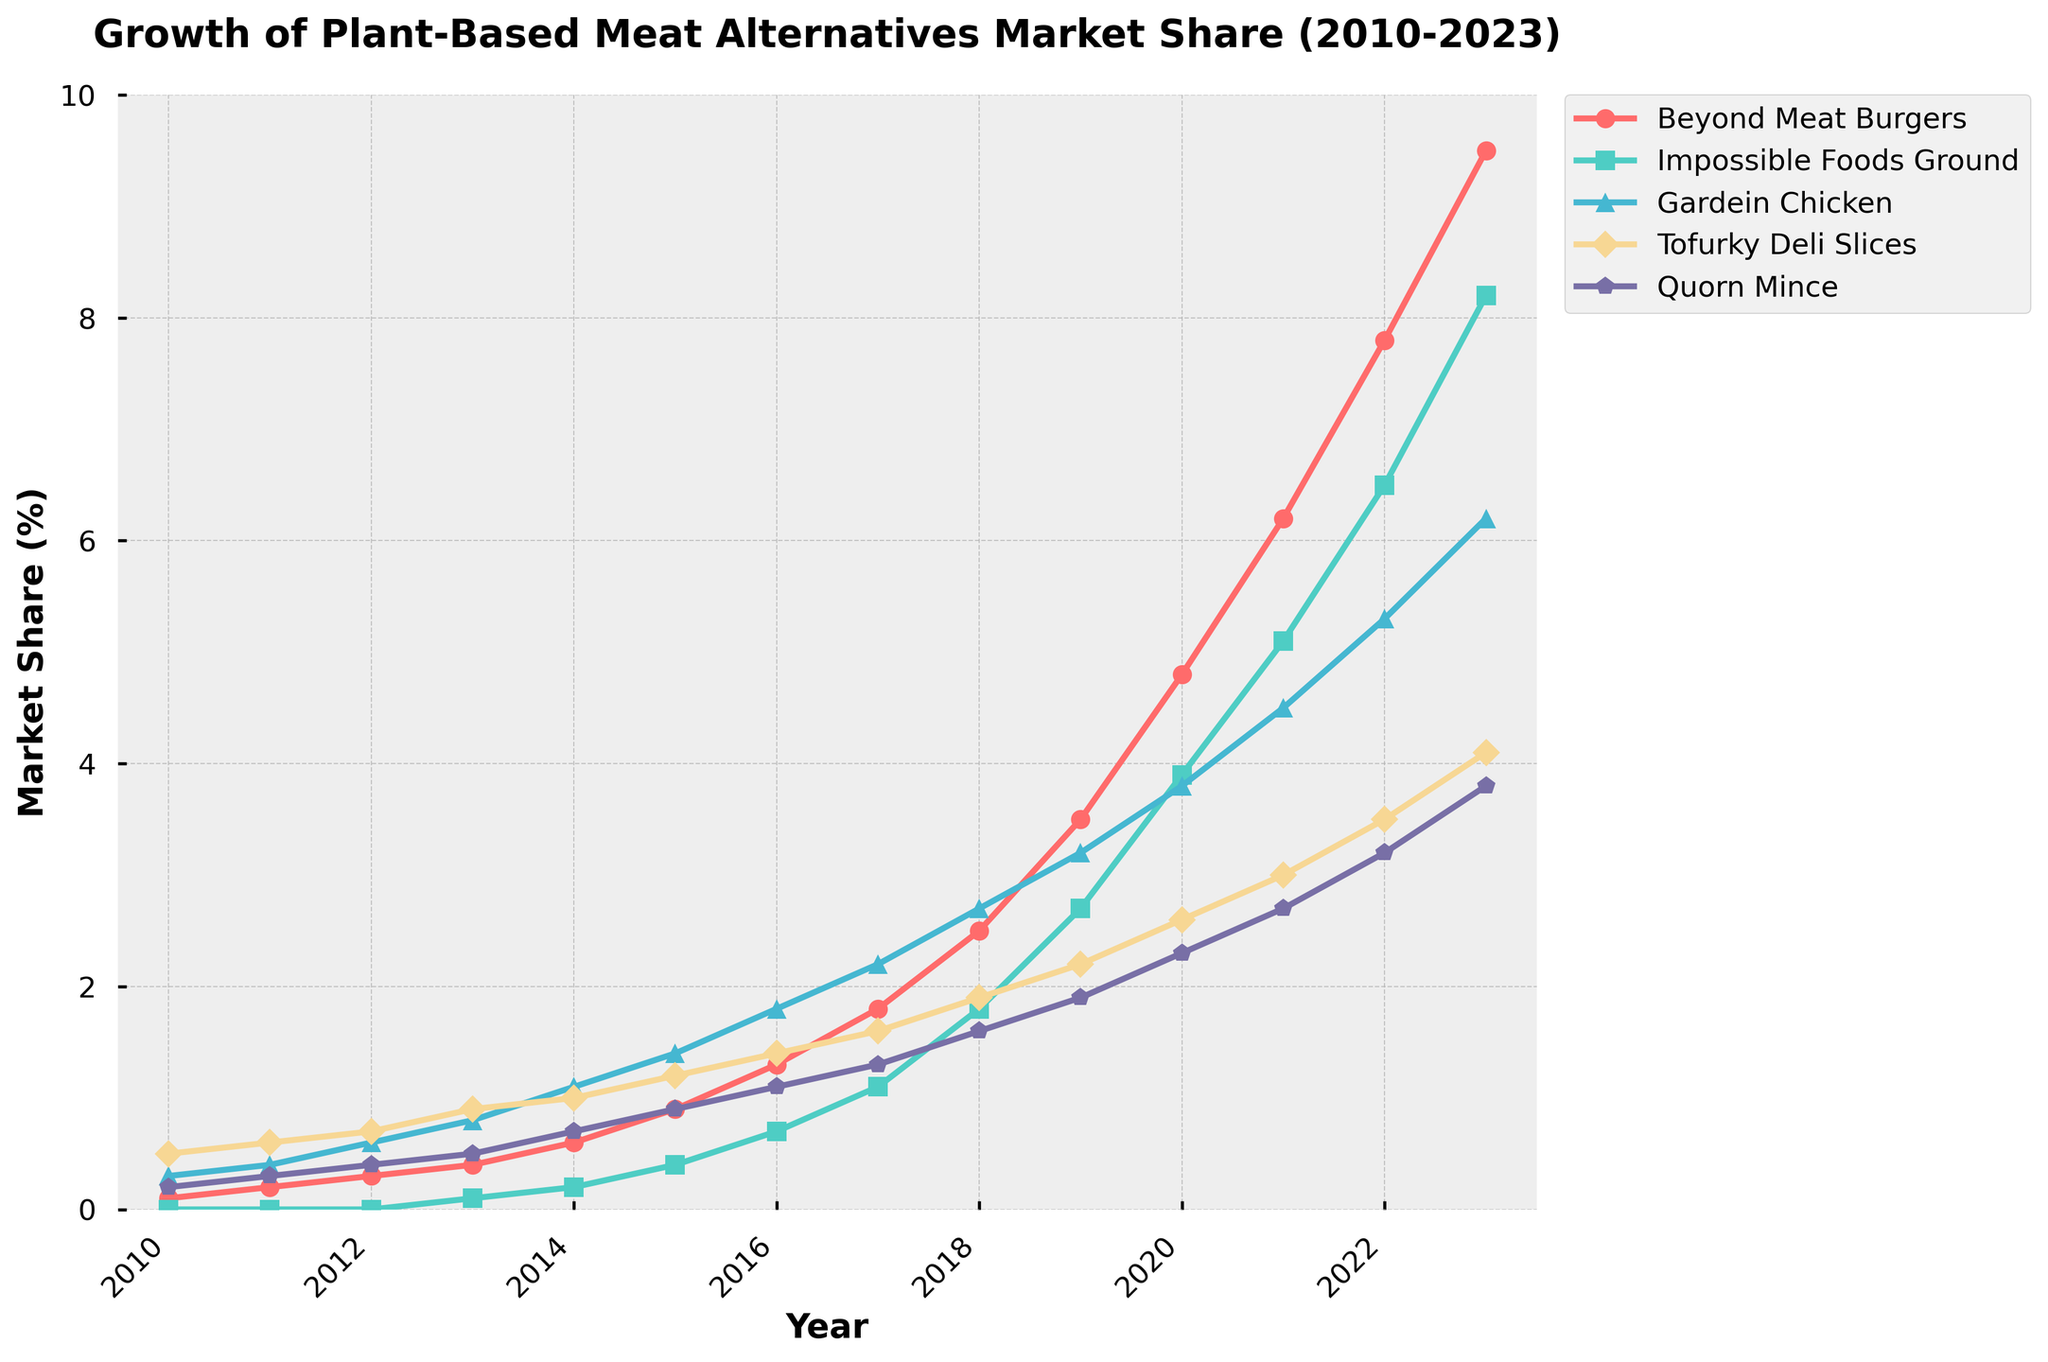What's the market share of Beyond Meat Burgers in 2023? To find the market share of Beyond Meat Burgers in 2023, look at the line corresponding to Beyond Meat Burgers and find the value where the line meets the year 2023. The market share value at this point is 9.5%.
Answer: 9.5% Between which years did Impossible Foods Ground see the most significant increase in market share? Identify the steepest upward segment on the line for Impossible Foods Ground. The line is steepest between 2021 and 2022, indicating the most significant increase in this period.
Answer: 2021-2022 How much did the market share of Gardein Chicken increase from 2010 to 2023? Find the difference between the market shares of Gardein Chicken in 2023 (6.2%) and 2010 (0.3%). The increase is 6.2% - 0.3% = 5.9%.
Answer: 5.9% Which product type had the highest market share in 2015? Look at the values for each type of product in 2015. Tofurky Deli Slices had the highest market share in 2015 with 1.2%.
Answer: Tofurky Deli Slices What was the average market share of Quorn Mince between 2020 and 2023? To find the average market share, sum the market shares of Quorn Mince from 2020 (2.3%), 2021 (2.7%), 2022 (3.2%), and 2023 (3.8%) and then divide by the number of years. The average is (2.3 + 2.7 + 3.2 + 3.8)/4 = 3.0%.
Answer: 3.0% Did any product have a market share of 0.0% at any point in the data provided? Look for any points on the lines that touch the x-axis (0.0% market share). Impossible Foods Ground had a market share of 0.0% from 2010 to 2012.
Answer: Yes How did the market share of Beyond Meat Burgers compare to Gardein Chicken in 2018? Check the values for both Beyond Meat Burgers and Gardein Chicken in 2018. Beyond Meat Burgers had a market share of 2.5%, while Gardein Chicken had a market share of 2.7%.
Answer: Gardein Chicken had a higher market share Which product showed the most consistent growth from 2010 to 2023? To determine the most consistent growth, look at the smoothness and steadiness of the lines. Beyond Meat Burgers show the most consistent upward trend without significant fluctuations.
Answer: Beyond Meat Burgers 